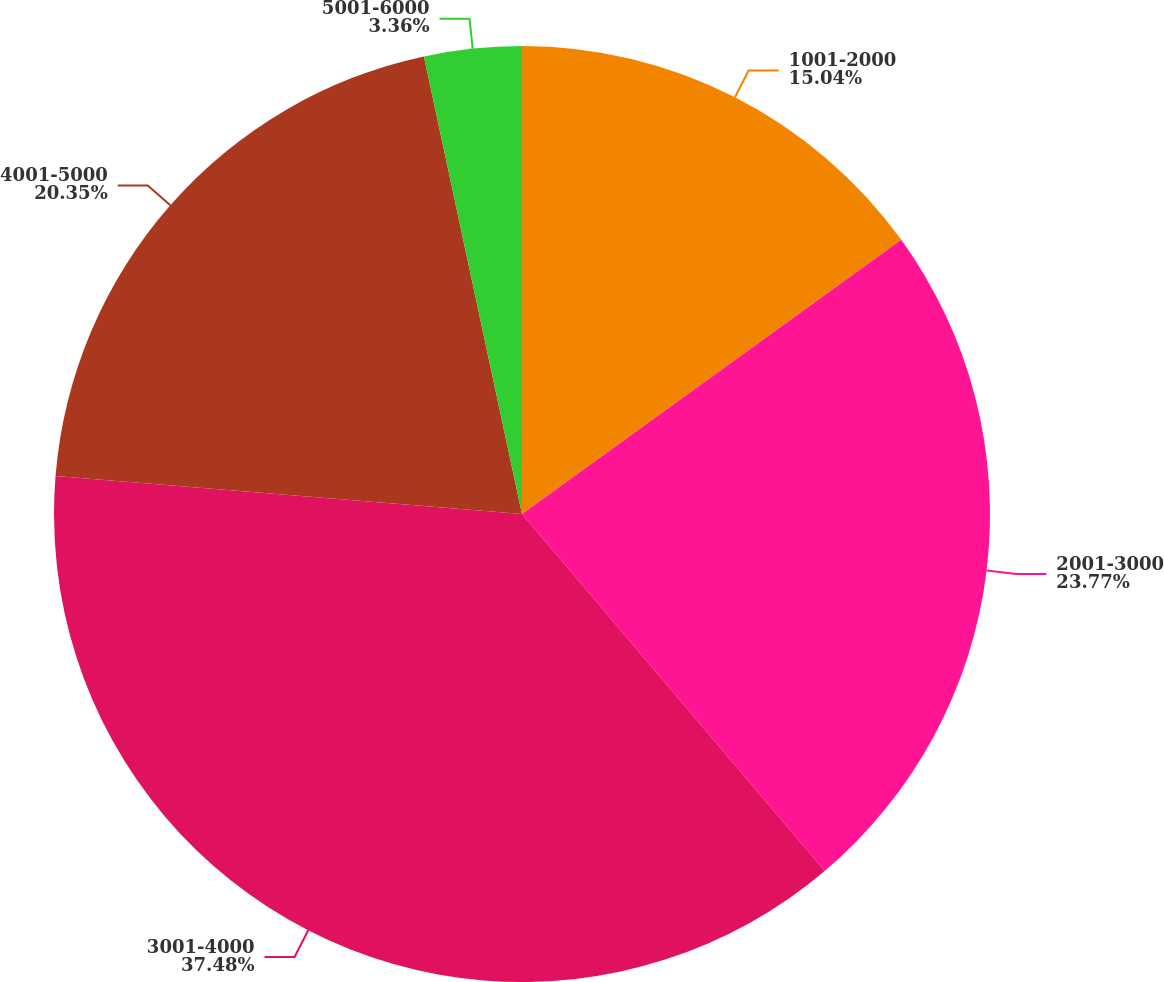Convert chart to OTSL. <chart><loc_0><loc_0><loc_500><loc_500><pie_chart><fcel>1001-2000<fcel>2001-3000<fcel>3001-4000<fcel>4001-5000<fcel>5001-6000<nl><fcel>15.04%<fcel>23.77%<fcel>37.49%<fcel>20.35%<fcel>3.36%<nl></chart> 